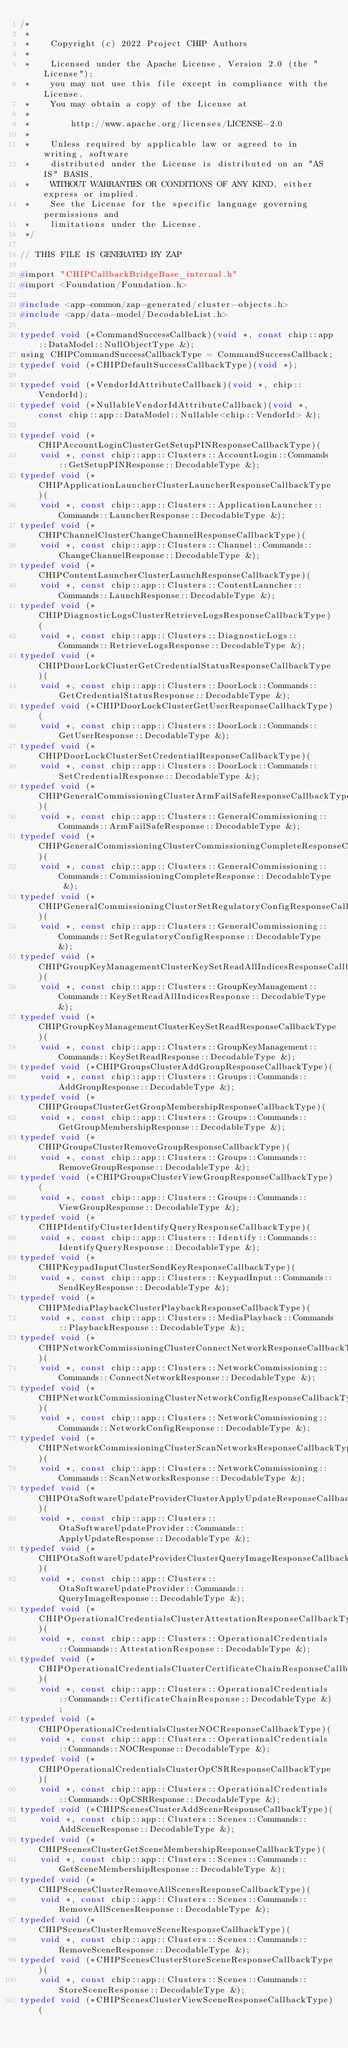<code> <loc_0><loc_0><loc_500><loc_500><_C_>/*
 *
 *    Copyright (c) 2022 Project CHIP Authors
 *
 *    Licensed under the Apache License, Version 2.0 (the "License");
 *    you may not use this file except in compliance with the License.
 *    You may obtain a copy of the License at
 *
 *        http://www.apache.org/licenses/LICENSE-2.0
 *
 *    Unless required by applicable law or agreed to in writing, software
 *    distributed under the License is distributed on an "AS IS" BASIS,
 *    WITHOUT WARRANTIES OR CONDITIONS OF ANY KIND, either express or implied.
 *    See the License for the specific language governing permissions and
 *    limitations under the License.
 */

// THIS FILE IS GENERATED BY ZAP

#import "CHIPCallbackBridgeBase_internal.h"
#import <Foundation/Foundation.h>

#include <app-common/zap-generated/cluster-objects.h>
#include <app/data-model/DecodableList.h>

typedef void (*CommandSuccessCallback)(void *, const chip::app::DataModel::NullObjectType &);
using CHIPCommandSuccessCallbackType = CommandSuccessCallback;
typedef void (*CHIPDefaultSuccessCallbackType)(void *);

typedef void (*VendorIdAttributeCallback)(void *, chip::VendorId);
typedef void (*NullableVendorIdAttributeCallback)(void *, const chip::app::DataModel::Nullable<chip::VendorId> &);

typedef void (*CHIPAccountLoginClusterGetSetupPINResponseCallbackType)(
    void *, const chip::app::Clusters::AccountLogin::Commands::GetSetupPINResponse::DecodableType &);
typedef void (*CHIPApplicationLauncherClusterLauncherResponseCallbackType)(
    void *, const chip::app::Clusters::ApplicationLauncher::Commands::LauncherResponse::DecodableType &);
typedef void (*CHIPChannelClusterChangeChannelResponseCallbackType)(
    void *, const chip::app::Clusters::Channel::Commands::ChangeChannelResponse::DecodableType &);
typedef void (*CHIPContentLauncherClusterLaunchResponseCallbackType)(
    void *, const chip::app::Clusters::ContentLauncher::Commands::LaunchResponse::DecodableType &);
typedef void (*CHIPDiagnosticLogsClusterRetrieveLogsResponseCallbackType)(
    void *, const chip::app::Clusters::DiagnosticLogs::Commands::RetrieveLogsResponse::DecodableType &);
typedef void (*CHIPDoorLockClusterGetCredentialStatusResponseCallbackType)(
    void *, const chip::app::Clusters::DoorLock::Commands::GetCredentialStatusResponse::DecodableType &);
typedef void (*CHIPDoorLockClusterGetUserResponseCallbackType)(
    void *, const chip::app::Clusters::DoorLock::Commands::GetUserResponse::DecodableType &);
typedef void (*CHIPDoorLockClusterSetCredentialResponseCallbackType)(
    void *, const chip::app::Clusters::DoorLock::Commands::SetCredentialResponse::DecodableType &);
typedef void (*CHIPGeneralCommissioningClusterArmFailSafeResponseCallbackType)(
    void *, const chip::app::Clusters::GeneralCommissioning::Commands::ArmFailSafeResponse::DecodableType &);
typedef void (*CHIPGeneralCommissioningClusterCommissioningCompleteResponseCallbackType)(
    void *, const chip::app::Clusters::GeneralCommissioning::Commands::CommissioningCompleteResponse::DecodableType &);
typedef void (*CHIPGeneralCommissioningClusterSetRegulatoryConfigResponseCallbackType)(
    void *, const chip::app::Clusters::GeneralCommissioning::Commands::SetRegulatoryConfigResponse::DecodableType &);
typedef void (*CHIPGroupKeyManagementClusterKeySetReadAllIndicesResponseCallbackType)(
    void *, const chip::app::Clusters::GroupKeyManagement::Commands::KeySetReadAllIndicesResponse::DecodableType &);
typedef void (*CHIPGroupKeyManagementClusterKeySetReadResponseCallbackType)(
    void *, const chip::app::Clusters::GroupKeyManagement::Commands::KeySetReadResponse::DecodableType &);
typedef void (*CHIPGroupsClusterAddGroupResponseCallbackType)(
    void *, const chip::app::Clusters::Groups::Commands::AddGroupResponse::DecodableType &);
typedef void (*CHIPGroupsClusterGetGroupMembershipResponseCallbackType)(
    void *, const chip::app::Clusters::Groups::Commands::GetGroupMembershipResponse::DecodableType &);
typedef void (*CHIPGroupsClusterRemoveGroupResponseCallbackType)(
    void *, const chip::app::Clusters::Groups::Commands::RemoveGroupResponse::DecodableType &);
typedef void (*CHIPGroupsClusterViewGroupResponseCallbackType)(
    void *, const chip::app::Clusters::Groups::Commands::ViewGroupResponse::DecodableType &);
typedef void (*CHIPIdentifyClusterIdentifyQueryResponseCallbackType)(
    void *, const chip::app::Clusters::Identify::Commands::IdentifyQueryResponse::DecodableType &);
typedef void (*CHIPKeypadInputClusterSendKeyResponseCallbackType)(
    void *, const chip::app::Clusters::KeypadInput::Commands::SendKeyResponse::DecodableType &);
typedef void (*CHIPMediaPlaybackClusterPlaybackResponseCallbackType)(
    void *, const chip::app::Clusters::MediaPlayback::Commands::PlaybackResponse::DecodableType &);
typedef void (*CHIPNetworkCommissioningClusterConnectNetworkResponseCallbackType)(
    void *, const chip::app::Clusters::NetworkCommissioning::Commands::ConnectNetworkResponse::DecodableType &);
typedef void (*CHIPNetworkCommissioningClusterNetworkConfigResponseCallbackType)(
    void *, const chip::app::Clusters::NetworkCommissioning::Commands::NetworkConfigResponse::DecodableType &);
typedef void (*CHIPNetworkCommissioningClusterScanNetworksResponseCallbackType)(
    void *, const chip::app::Clusters::NetworkCommissioning::Commands::ScanNetworksResponse::DecodableType &);
typedef void (*CHIPOtaSoftwareUpdateProviderClusterApplyUpdateResponseCallbackType)(
    void *, const chip::app::Clusters::OtaSoftwareUpdateProvider::Commands::ApplyUpdateResponse::DecodableType &);
typedef void (*CHIPOtaSoftwareUpdateProviderClusterQueryImageResponseCallbackType)(
    void *, const chip::app::Clusters::OtaSoftwareUpdateProvider::Commands::QueryImageResponse::DecodableType &);
typedef void (*CHIPOperationalCredentialsClusterAttestationResponseCallbackType)(
    void *, const chip::app::Clusters::OperationalCredentials::Commands::AttestationResponse::DecodableType &);
typedef void (*CHIPOperationalCredentialsClusterCertificateChainResponseCallbackType)(
    void *, const chip::app::Clusters::OperationalCredentials::Commands::CertificateChainResponse::DecodableType &);
typedef void (*CHIPOperationalCredentialsClusterNOCResponseCallbackType)(
    void *, const chip::app::Clusters::OperationalCredentials::Commands::NOCResponse::DecodableType &);
typedef void (*CHIPOperationalCredentialsClusterOpCSRResponseCallbackType)(
    void *, const chip::app::Clusters::OperationalCredentials::Commands::OpCSRResponse::DecodableType &);
typedef void (*CHIPScenesClusterAddSceneResponseCallbackType)(
    void *, const chip::app::Clusters::Scenes::Commands::AddSceneResponse::DecodableType &);
typedef void (*CHIPScenesClusterGetSceneMembershipResponseCallbackType)(
    void *, const chip::app::Clusters::Scenes::Commands::GetSceneMembershipResponse::DecodableType &);
typedef void (*CHIPScenesClusterRemoveAllScenesResponseCallbackType)(
    void *, const chip::app::Clusters::Scenes::Commands::RemoveAllScenesResponse::DecodableType &);
typedef void (*CHIPScenesClusterRemoveSceneResponseCallbackType)(
    void *, const chip::app::Clusters::Scenes::Commands::RemoveSceneResponse::DecodableType &);
typedef void (*CHIPScenesClusterStoreSceneResponseCallbackType)(
    void *, const chip::app::Clusters::Scenes::Commands::StoreSceneResponse::DecodableType &);
typedef void (*CHIPScenesClusterViewSceneResponseCallbackType)(</code> 